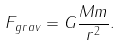<formula> <loc_0><loc_0><loc_500><loc_500>F _ { g r a v } = G \frac { M m } { r ^ { 2 } } .</formula> 